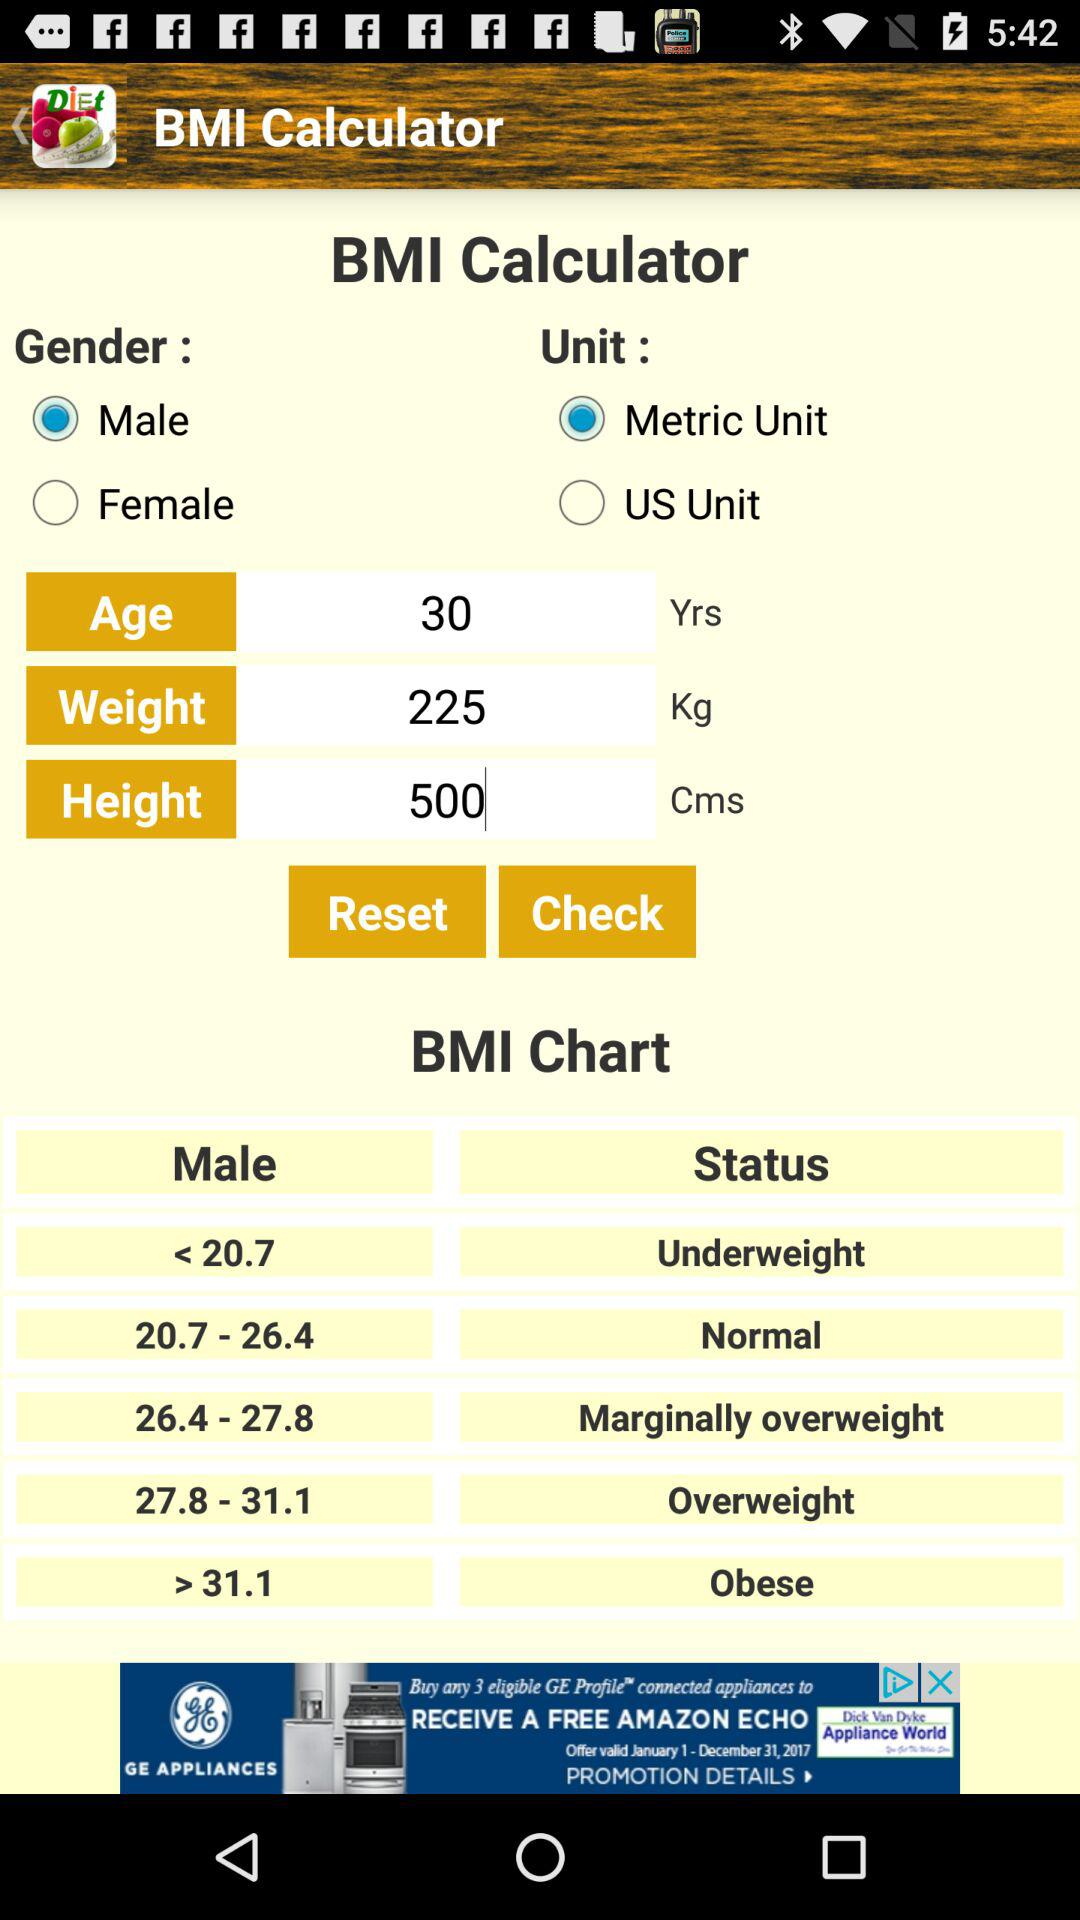Which gender is selected? The selected gender is male. 